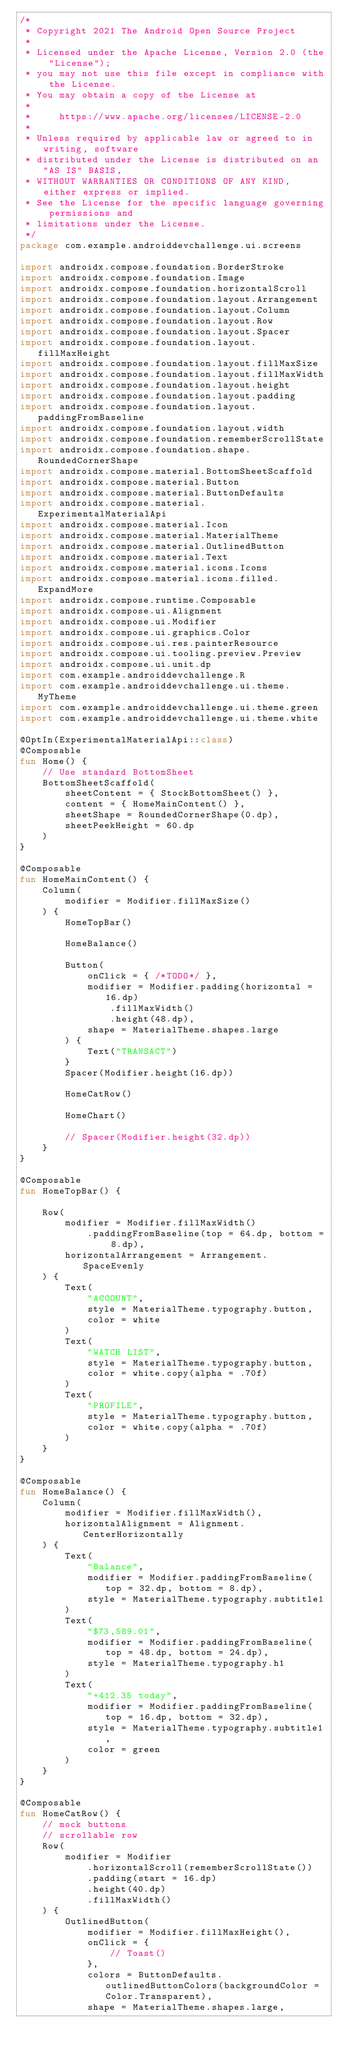<code> <loc_0><loc_0><loc_500><loc_500><_Kotlin_>/*
 * Copyright 2021 The Android Open Source Project
 *
 * Licensed under the Apache License, Version 2.0 (the "License");
 * you may not use this file except in compliance with the License.
 * You may obtain a copy of the License at
 *
 *     https://www.apache.org/licenses/LICENSE-2.0
 *
 * Unless required by applicable law or agreed to in writing, software
 * distributed under the License is distributed on an "AS IS" BASIS,
 * WITHOUT WARRANTIES OR CONDITIONS OF ANY KIND, either express or implied.
 * See the License for the specific language governing permissions and
 * limitations under the License.
 */
package com.example.androiddevchallenge.ui.screens

import androidx.compose.foundation.BorderStroke
import androidx.compose.foundation.Image
import androidx.compose.foundation.horizontalScroll
import androidx.compose.foundation.layout.Arrangement
import androidx.compose.foundation.layout.Column
import androidx.compose.foundation.layout.Row
import androidx.compose.foundation.layout.Spacer
import androidx.compose.foundation.layout.fillMaxHeight
import androidx.compose.foundation.layout.fillMaxSize
import androidx.compose.foundation.layout.fillMaxWidth
import androidx.compose.foundation.layout.height
import androidx.compose.foundation.layout.padding
import androidx.compose.foundation.layout.paddingFromBaseline
import androidx.compose.foundation.layout.width
import androidx.compose.foundation.rememberScrollState
import androidx.compose.foundation.shape.RoundedCornerShape
import androidx.compose.material.BottomSheetScaffold
import androidx.compose.material.Button
import androidx.compose.material.ButtonDefaults
import androidx.compose.material.ExperimentalMaterialApi
import androidx.compose.material.Icon
import androidx.compose.material.MaterialTheme
import androidx.compose.material.OutlinedButton
import androidx.compose.material.Text
import androidx.compose.material.icons.Icons
import androidx.compose.material.icons.filled.ExpandMore
import androidx.compose.runtime.Composable
import androidx.compose.ui.Alignment
import androidx.compose.ui.Modifier
import androidx.compose.ui.graphics.Color
import androidx.compose.ui.res.painterResource
import androidx.compose.ui.tooling.preview.Preview
import androidx.compose.ui.unit.dp
import com.example.androiddevchallenge.R
import com.example.androiddevchallenge.ui.theme.MyTheme
import com.example.androiddevchallenge.ui.theme.green
import com.example.androiddevchallenge.ui.theme.white

@OptIn(ExperimentalMaterialApi::class)
@Composable
fun Home() {
    // Use standard BottomSheet
    BottomSheetScaffold(
        sheetContent = { StockBottomSheet() },
        content = { HomeMainContent() },
        sheetShape = RoundedCornerShape(0.dp),
        sheetPeekHeight = 60.dp
    )
}

@Composable
fun HomeMainContent() {
    Column(
        modifier = Modifier.fillMaxSize()
    ) {
        HomeTopBar()

        HomeBalance()

        Button(
            onClick = { /*TODO*/ },
            modifier = Modifier.padding(horizontal = 16.dp)
                .fillMaxWidth()
                .height(48.dp),
            shape = MaterialTheme.shapes.large
        ) {
            Text("TRANSACT")
        }
        Spacer(Modifier.height(16.dp))

        HomeCatRow()

        HomeChart()

        // Spacer(Modifier.height(32.dp))
    }
}

@Composable
fun HomeTopBar() {

    Row(
        modifier = Modifier.fillMaxWidth()
            .paddingFromBaseline(top = 64.dp, bottom = 8.dp),
        horizontalArrangement = Arrangement.SpaceEvenly
    ) {
        Text(
            "ACCOUNT",
            style = MaterialTheme.typography.button,
            color = white
        )
        Text(
            "WATCH LIST",
            style = MaterialTheme.typography.button,
            color = white.copy(alpha = .70f)
        )
        Text(
            "PROFILE",
            style = MaterialTheme.typography.button,
            color = white.copy(alpha = .70f)
        )
    }
}

@Composable
fun HomeBalance() {
    Column(
        modifier = Modifier.fillMaxWidth(),
        horizontalAlignment = Alignment.CenterHorizontally
    ) {
        Text(
            "Balance",
            modifier = Modifier.paddingFromBaseline(top = 32.dp, bottom = 8.dp),
            style = MaterialTheme.typography.subtitle1
        )
        Text(
            "$73,589.01",
            modifier = Modifier.paddingFromBaseline(top = 48.dp, bottom = 24.dp),
            style = MaterialTheme.typography.h1
        )
        Text(
            "+412.35 today",
            modifier = Modifier.paddingFromBaseline(top = 16.dp, bottom = 32.dp),
            style = MaterialTheme.typography.subtitle1,
            color = green
        )
    }
}

@Composable
fun HomeCatRow() {
    // mock buttons
    // scrollable row
    Row(
        modifier = Modifier
            .horizontalScroll(rememberScrollState())
            .padding(start = 16.dp)
            .height(40.dp)
            .fillMaxWidth()
    ) {
        OutlinedButton(
            modifier = Modifier.fillMaxHeight(),
            onClick = {
                // Toast()
            },
            colors = ButtonDefaults.outlinedButtonColors(backgroundColor = Color.Transparent),
            shape = MaterialTheme.shapes.large,</code> 